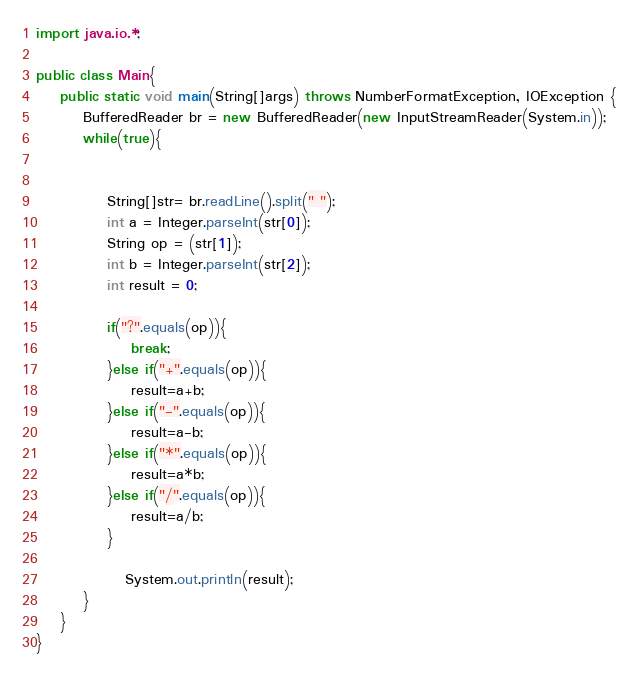<code> <loc_0><loc_0><loc_500><loc_500><_Java_>import java.io.*;

public class Main{
    public static void main(String[]args) throws NumberFormatException, IOException {
        BufferedReader br = new BufferedReader(new InputStreamReader(System.in));
        while(true){
            

            String[]str= br.readLine().split(" ");
            int a = Integer.parseInt(str[0]);
            String op = (str[1]);
            int b = Integer.parseInt(str[2]);
            int result = 0;
            
            if("?".equals(op)){
                break;
            }else if("+".equals(op)){
                result=a+b;
            }else if("-".equals(op)){
                result=a-b;
            }else if("*".equals(op)){
                result=a*b;
            }else if("/".equals(op)){
                result=a/b;
            }
           
               System.out.println(result);
        }
    }
}</code> 